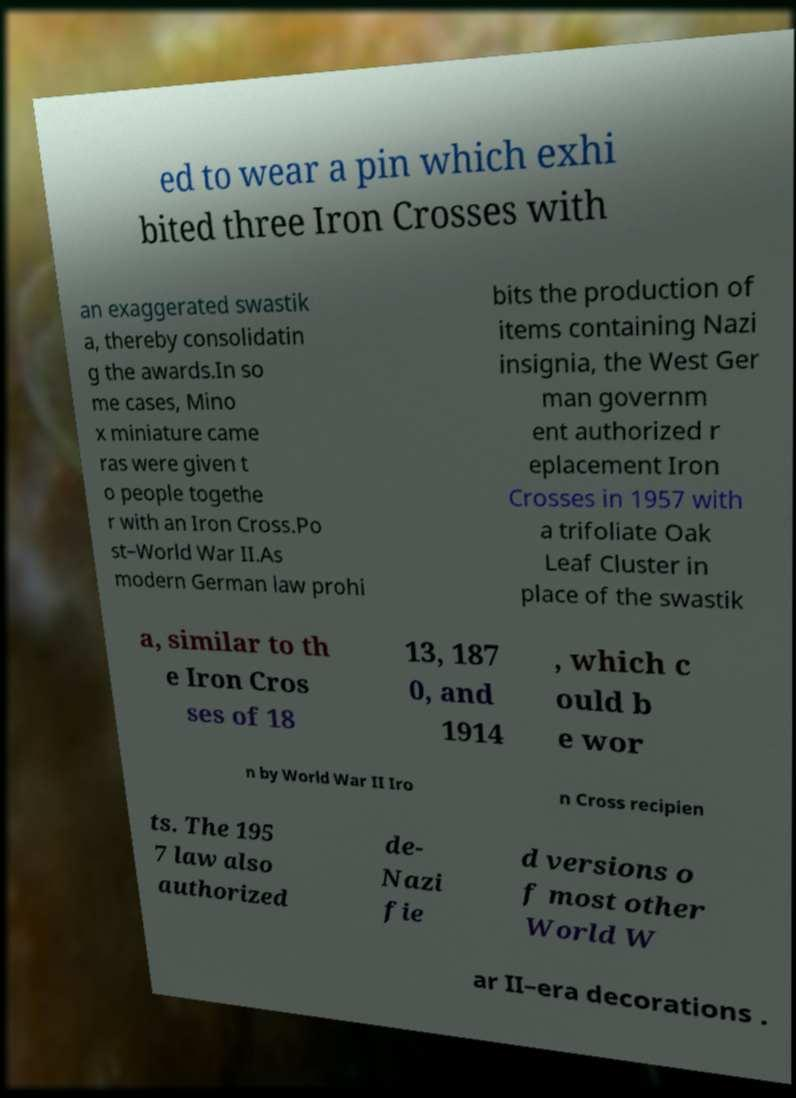For documentation purposes, I need the text within this image transcribed. Could you provide that? ed to wear a pin which exhi bited three Iron Crosses with an exaggerated swastik a, thereby consolidatin g the awards.In so me cases, Mino x miniature came ras were given t o people togethe r with an Iron Cross.Po st–World War II.As modern German law prohi bits the production of items containing Nazi insignia, the West Ger man governm ent authorized r eplacement Iron Crosses in 1957 with a trifoliate Oak Leaf Cluster in place of the swastik a, similar to th e Iron Cros ses of 18 13, 187 0, and 1914 , which c ould b e wor n by World War II Iro n Cross recipien ts. The 195 7 law also authorized de- Nazi fie d versions o f most other World W ar II–era decorations . 